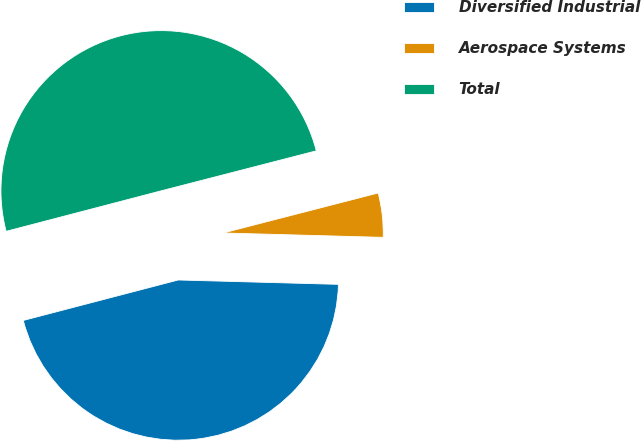Convert chart. <chart><loc_0><loc_0><loc_500><loc_500><pie_chart><fcel>Diversified Industrial<fcel>Aerospace Systems<fcel>Total<nl><fcel>45.5%<fcel>4.45%<fcel>50.05%<nl></chart> 